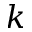Convert formula to latex. <formula><loc_0><loc_0><loc_500><loc_500>k</formula> 